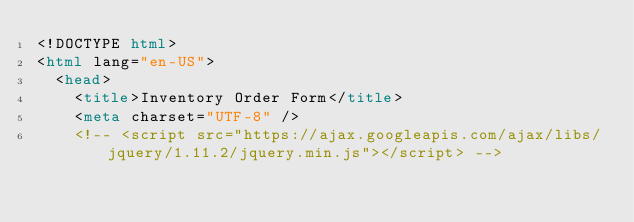<code> <loc_0><loc_0><loc_500><loc_500><_HTML_><!DOCTYPE html>
<html lang="en-US">
  <head>
    <title>Inventory Order Form</title>
    <meta charset="UTF-8" />
    <!-- <script src="https://ajax.googleapis.com/ajax/libs/jquery/1.11.2/jquery.min.js"></script> --></code> 